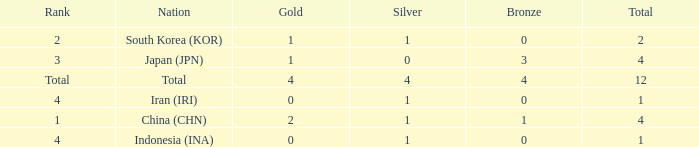How many silver medals for the nation with fewer than 1 golds and total less than 1? 0.0. 